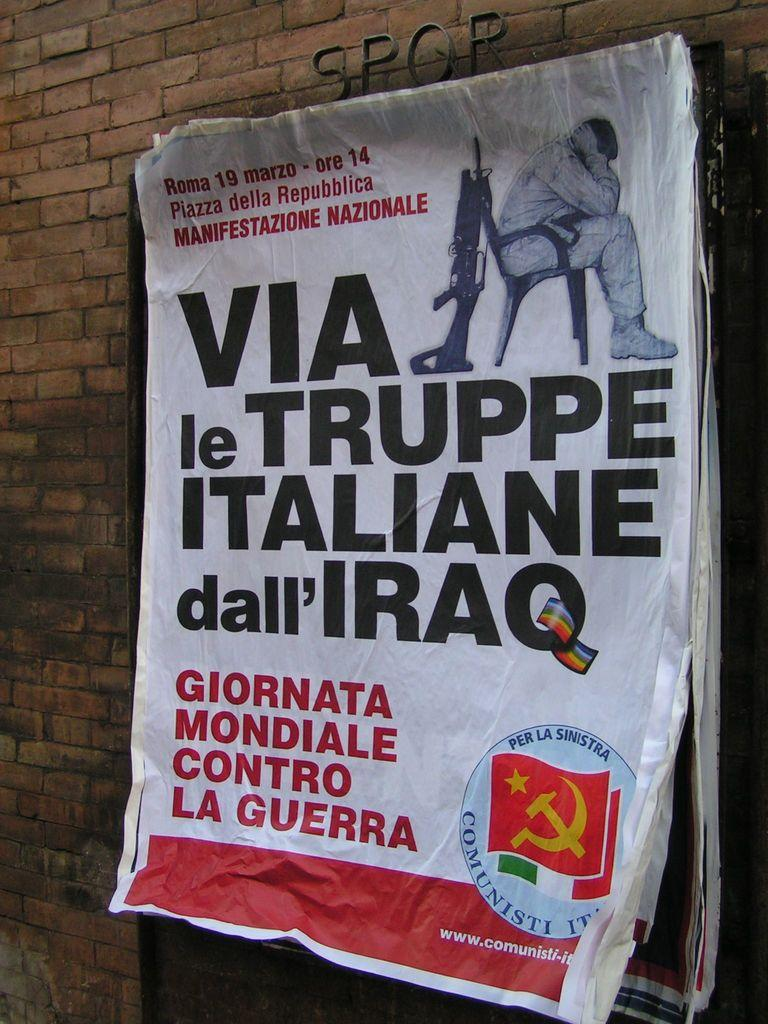<image>
Write a terse but informative summary of the picture. Poster on a wall that says "Giornata Mondiale" in red letters. 